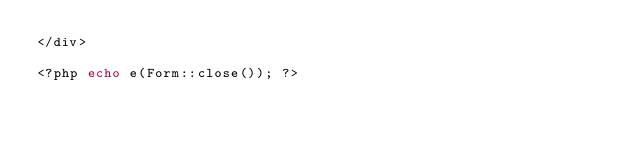<code> <loc_0><loc_0><loc_500><loc_500><_PHP_></div>

<?php echo e(Form::close()); ?> </code> 